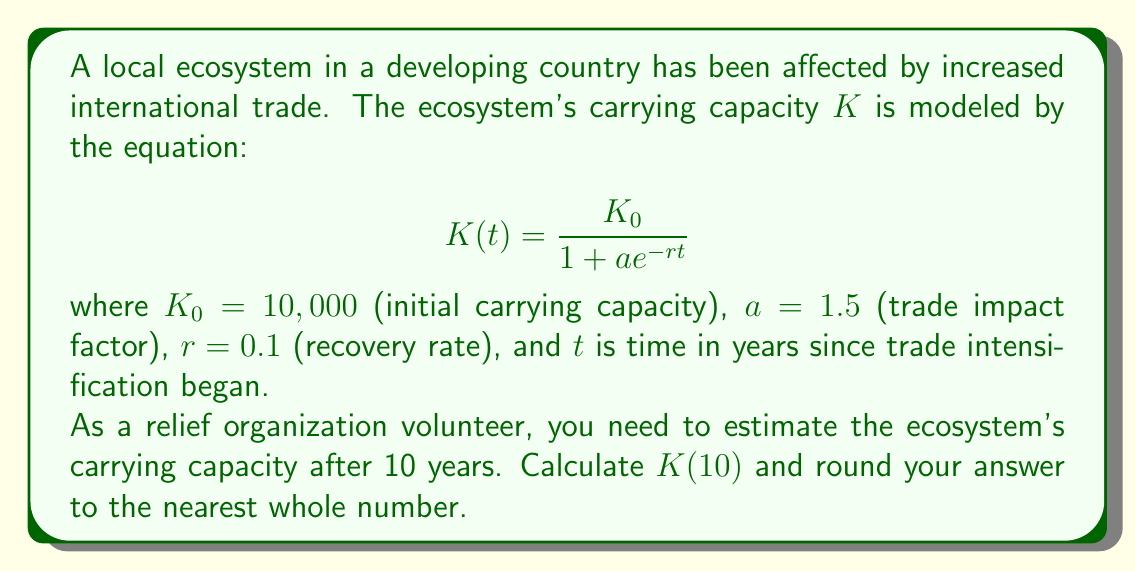Provide a solution to this math problem. To solve this problem, we'll follow these steps:

1) We're given the logistic growth model for carrying capacity:
   $$K(t) = \frac{K_0}{1 + ae^{-rt}}$$

2) We know the following parameters:
   $K_0 = 10,000$
   $a = 1.5$
   $r = 0.1$
   $t = 10$

3) Let's substitute these values into the equation:
   $$K(10) = \frac{10,000}{1 + 1.5e^{-0.1(10)}}$$

4) First, let's calculate the exponent:
   $-0.1(10) = -1$

5) Now, we can simplify the denominator:
   $$K(10) = \frac{10,000}{1 + 1.5e^{-1}}$$

6) Calculate $e^{-1}$:
   $e^{-1} \approx 0.3679$

7) Multiply by 1.5:
   $1.5 * 0.3679 \approx 0.5518$

8) Add 1 to this result:
   $1 + 0.5518 = 1.5518$

9) Now we can divide:
   $$K(10) = \frac{10,000}{1.5518} \approx 6443.49$$

10) Rounding to the nearest whole number:
    $K(10) \approx 6443$

This result indicates that after 10 years of increased international trade, the ecosystem's carrying capacity has decreased from its initial value of 10,000 to approximately 6,443.
Answer: 6443 